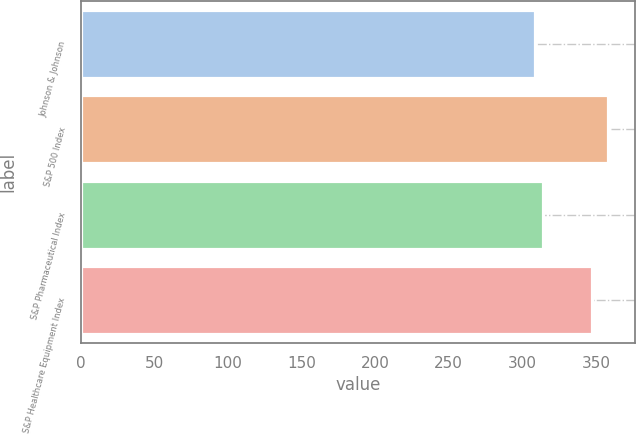Convert chart to OTSL. <chart><loc_0><loc_0><loc_500><loc_500><bar_chart><fcel>Johnson & Johnson<fcel>S&P 500 Index<fcel>S&P Pharmaceutical Index<fcel>S&P Healthcare Equipment Index<nl><fcel>308.85<fcel>358.5<fcel>313.81<fcel>347.17<nl></chart> 